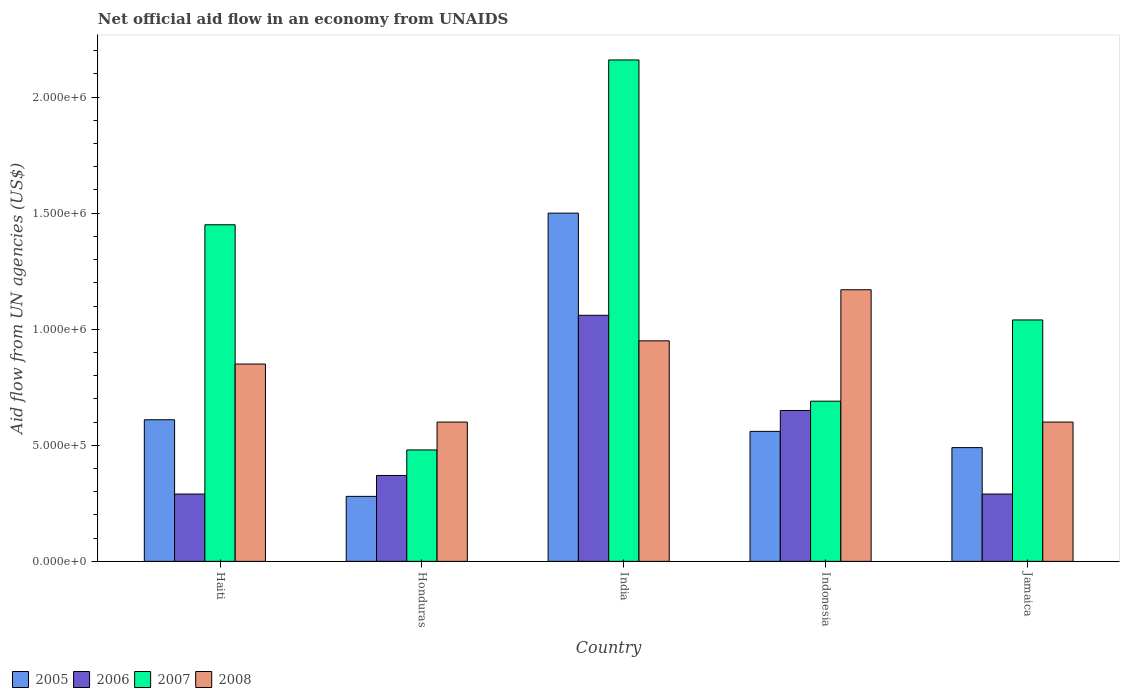How many groups of bars are there?
Offer a terse response. 5. Are the number of bars per tick equal to the number of legend labels?
Give a very brief answer. Yes. Are the number of bars on each tick of the X-axis equal?
Your answer should be compact. Yes. What is the label of the 5th group of bars from the left?
Offer a terse response. Jamaica. In how many cases, is the number of bars for a given country not equal to the number of legend labels?
Your response must be concise. 0. Across all countries, what is the maximum net official aid flow in 2008?
Your response must be concise. 1.17e+06. In which country was the net official aid flow in 2007 maximum?
Keep it short and to the point. India. In which country was the net official aid flow in 2007 minimum?
Provide a short and direct response. Honduras. What is the total net official aid flow in 2008 in the graph?
Provide a succinct answer. 4.17e+06. What is the difference between the net official aid flow in 2006 in Honduras and the net official aid flow in 2005 in India?
Your response must be concise. -1.13e+06. What is the average net official aid flow in 2008 per country?
Your answer should be very brief. 8.34e+05. What is the difference between the net official aid flow of/in 2008 and net official aid flow of/in 2005 in Jamaica?
Offer a terse response. 1.10e+05. In how many countries, is the net official aid flow in 2008 greater than 900000 US$?
Your response must be concise. 2. What is the difference between the highest and the second highest net official aid flow in 2005?
Your response must be concise. 9.40e+05. What is the difference between the highest and the lowest net official aid flow in 2005?
Your response must be concise. 1.22e+06. In how many countries, is the net official aid flow in 2007 greater than the average net official aid flow in 2007 taken over all countries?
Your answer should be very brief. 2. Is the sum of the net official aid flow in 2005 in India and Indonesia greater than the maximum net official aid flow in 2007 across all countries?
Ensure brevity in your answer.  No. Is it the case that in every country, the sum of the net official aid flow in 2005 and net official aid flow in 2007 is greater than the net official aid flow in 2006?
Make the answer very short. Yes. How many bars are there?
Keep it short and to the point. 20. Does the graph contain grids?
Provide a succinct answer. No. Where does the legend appear in the graph?
Offer a very short reply. Bottom left. How many legend labels are there?
Provide a short and direct response. 4. How are the legend labels stacked?
Offer a very short reply. Horizontal. What is the title of the graph?
Ensure brevity in your answer.  Net official aid flow in an economy from UNAIDS. What is the label or title of the X-axis?
Ensure brevity in your answer.  Country. What is the label or title of the Y-axis?
Offer a terse response. Aid flow from UN agencies (US$). What is the Aid flow from UN agencies (US$) of 2005 in Haiti?
Provide a succinct answer. 6.10e+05. What is the Aid flow from UN agencies (US$) of 2006 in Haiti?
Your answer should be compact. 2.90e+05. What is the Aid flow from UN agencies (US$) in 2007 in Haiti?
Your answer should be compact. 1.45e+06. What is the Aid flow from UN agencies (US$) of 2008 in Haiti?
Provide a short and direct response. 8.50e+05. What is the Aid flow from UN agencies (US$) of 2005 in India?
Keep it short and to the point. 1.50e+06. What is the Aid flow from UN agencies (US$) of 2006 in India?
Keep it short and to the point. 1.06e+06. What is the Aid flow from UN agencies (US$) of 2007 in India?
Keep it short and to the point. 2.16e+06. What is the Aid flow from UN agencies (US$) in 2008 in India?
Your answer should be very brief. 9.50e+05. What is the Aid flow from UN agencies (US$) of 2005 in Indonesia?
Provide a succinct answer. 5.60e+05. What is the Aid flow from UN agencies (US$) in 2006 in Indonesia?
Keep it short and to the point. 6.50e+05. What is the Aid flow from UN agencies (US$) of 2007 in Indonesia?
Ensure brevity in your answer.  6.90e+05. What is the Aid flow from UN agencies (US$) of 2008 in Indonesia?
Offer a terse response. 1.17e+06. What is the Aid flow from UN agencies (US$) in 2007 in Jamaica?
Offer a terse response. 1.04e+06. Across all countries, what is the maximum Aid flow from UN agencies (US$) in 2005?
Offer a very short reply. 1.50e+06. Across all countries, what is the maximum Aid flow from UN agencies (US$) of 2006?
Provide a short and direct response. 1.06e+06. Across all countries, what is the maximum Aid flow from UN agencies (US$) of 2007?
Your answer should be very brief. 2.16e+06. Across all countries, what is the maximum Aid flow from UN agencies (US$) in 2008?
Your answer should be very brief. 1.17e+06. Across all countries, what is the minimum Aid flow from UN agencies (US$) of 2006?
Ensure brevity in your answer.  2.90e+05. What is the total Aid flow from UN agencies (US$) in 2005 in the graph?
Keep it short and to the point. 3.44e+06. What is the total Aid flow from UN agencies (US$) in 2006 in the graph?
Your answer should be compact. 2.66e+06. What is the total Aid flow from UN agencies (US$) of 2007 in the graph?
Your answer should be compact. 5.82e+06. What is the total Aid flow from UN agencies (US$) in 2008 in the graph?
Your answer should be compact. 4.17e+06. What is the difference between the Aid flow from UN agencies (US$) in 2005 in Haiti and that in Honduras?
Keep it short and to the point. 3.30e+05. What is the difference between the Aid flow from UN agencies (US$) of 2007 in Haiti and that in Honduras?
Offer a terse response. 9.70e+05. What is the difference between the Aid flow from UN agencies (US$) of 2008 in Haiti and that in Honduras?
Give a very brief answer. 2.50e+05. What is the difference between the Aid flow from UN agencies (US$) of 2005 in Haiti and that in India?
Provide a short and direct response. -8.90e+05. What is the difference between the Aid flow from UN agencies (US$) in 2006 in Haiti and that in India?
Offer a very short reply. -7.70e+05. What is the difference between the Aid flow from UN agencies (US$) in 2007 in Haiti and that in India?
Make the answer very short. -7.10e+05. What is the difference between the Aid flow from UN agencies (US$) in 2008 in Haiti and that in India?
Your answer should be compact. -1.00e+05. What is the difference between the Aid flow from UN agencies (US$) in 2005 in Haiti and that in Indonesia?
Give a very brief answer. 5.00e+04. What is the difference between the Aid flow from UN agencies (US$) of 2006 in Haiti and that in Indonesia?
Your answer should be compact. -3.60e+05. What is the difference between the Aid flow from UN agencies (US$) of 2007 in Haiti and that in Indonesia?
Provide a short and direct response. 7.60e+05. What is the difference between the Aid flow from UN agencies (US$) in 2008 in Haiti and that in Indonesia?
Your answer should be very brief. -3.20e+05. What is the difference between the Aid flow from UN agencies (US$) in 2007 in Haiti and that in Jamaica?
Your answer should be very brief. 4.10e+05. What is the difference between the Aid flow from UN agencies (US$) in 2008 in Haiti and that in Jamaica?
Make the answer very short. 2.50e+05. What is the difference between the Aid flow from UN agencies (US$) of 2005 in Honduras and that in India?
Offer a very short reply. -1.22e+06. What is the difference between the Aid flow from UN agencies (US$) in 2006 in Honduras and that in India?
Your answer should be compact. -6.90e+05. What is the difference between the Aid flow from UN agencies (US$) in 2007 in Honduras and that in India?
Your response must be concise. -1.68e+06. What is the difference between the Aid flow from UN agencies (US$) in 2008 in Honduras and that in India?
Your answer should be very brief. -3.50e+05. What is the difference between the Aid flow from UN agencies (US$) of 2005 in Honduras and that in Indonesia?
Ensure brevity in your answer.  -2.80e+05. What is the difference between the Aid flow from UN agencies (US$) of 2006 in Honduras and that in Indonesia?
Make the answer very short. -2.80e+05. What is the difference between the Aid flow from UN agencies (US$) of 2008 in Honduras and that in Indonesia?
Make the answer very short. -5.70e+05. What is the difference between the Aid flow from UN agencies (US$) of 2005 in Honduras and that in Jamaica?
Your answer should be compact. -2.10e+05. What is the difference between the Aid flow from UN agencies (US$) in 2007 in Honduras and that in Jamaica?
Your response must be concise. -5.60e+05. What is the difference between the Aid flow from UN agencies (US$) of 2005 in India and that in Indonesia?
Your response must be concise. 9.40e+05. What is the difference between the Aid flow from UN agencies (US$) in 2007 in India and that in Indonesia?
Your answer should be compact. 1.47e+06. What is the difference between the Aid flow from UN agencies (US$) in 2008 in India and that in Indonesia?
Ensure brevity in your answer.  -2.20e+05. What is the difference between the Aid flow from UN agencies (US$) in 2005 in India and that in Jamaica?
Your response must be concise. 1.01e+06. What is the difference between the Aid flow from UN agencies (US$) in 2006 in India and that in Jamaica?
Your response must be concise. 7.70e+05. What is the difference between the Aid flow from UN agencies (US$) of 2007 in India and that in Jamaica?
Ensure brevity in your answer.  1.12e+06. What is the difference between the Aid flow from UN agencies (US$) of 2007 in Indonesia and that in Jamaica?
Your response must be concise. -3.50e+05. What is the difference between the Aid flow from UN agencies (US$) of 2008 in Indonesia and that in Jamaica?
Ensure brevity in your answer.  5.70e+05. What is the difference between the Aid flow from UN agencies (US$) in 2005 in Haiti and the Aid flow from UN agencies (US$) in 2007 in Honduras?
Provide a short and direct response. 1.30e+05. What is the difference between the Aid flow from UN agencies (US$) of 2006 in Haiti and the Aid flow from UN agencies (US$) of 2008 in Honduras?
Your response must be concise. -3.10e+05. What is the difference between the Aid flow from UN agencies (US$) in 2007 in Haiti and the Aid flow from UN agencies (US$) in 2008 in Honduras?
Give a very brief answer. 8.50e+05. What is the difference between the Aid flow from UN agencies (US$) of 2005 in Haiti and the Aid flow from UN agencies (US$) of 2006 in India?
Keep it short and to the point. -4.50e+05. What is the difference between the Aid flow from UN agencies (US$) in 2005 in Haiti and the Aid flow from UN agencies (US$) in 2007 in India?
Your answer should be very brief. -1.55e+06. What is the difference between the Aid flow from UN agencies (US$) in 2006 in Haiti and the Aid flow from UN agencies (US$) in 2007 in India?
Your answer should be compact. -1.87e+06. What is the difference between the Aid flow from UN agencies (US$) of 2006 in Haiti and the Aid flow from UN agencies (US$) of 2008 in India?
Ensure brevity in your answer.  -6.60e+05. What is the difference between the Aid flow from UN agencies (US$) in 2007 in Haiti and the Aid flow from UN agencies (US$) in 2008 in India?
Provide a succinct answer. 5.00e+05. What is the difference between the Aid flow from UN agencies (US$) in 2005 in Haiti and the Aid flow from UN agencies (US$) in 2008 in Indonesia?
Make the answer very short. -5.60e+05. What is the difference between the Aid flow from UN agencies (US$) of 2006 in Haiti and the Aid flow from UN agencies (US$) of 2007 in Indonesia?
Your response must be concise. -4.00e+05. What is the difference between the Aid flow from UN agencies (US$) in 2006 in Haiti and the Aid flow from UN agencies (US$) in 2008 in Indonesia?
Offer a terse response. -8.80e+05. What is the difference between the Aid flow from UN agencies (US$) of 2005 in Haiti and the Aid flow from UN agencies (US$) of 2006 in Jamaica?
Your answer should be very brief. 3.20e+05. What is the difference between the Aid flow from UN agencies (US$) of 2005 in Haiti and the Aid flow from UN agencies (US$) of 2007 in Jamaica?
Make the answer very short. -4.30e+05. What is the difference between the Aid flow from UN agencies (US$) of 2005 in Haiti and the Aid flow from UN agencies (US$) of 2008 in Jamaica?
Your response must be concise. 10000. What is the difference between the Aid flow from UN agencies (US$) in 2006 in Haiti and the Aid flow from UN agencies (US$) in 2007 in Jamaica?
Keep it short and to the point. -7.50e+05. What is the difference between the Aid flow from UN agencies (US$) of 2006 in Haiti and the Aid flow from UN agencies (US$) of 2008 in Jamaica?
Offer a very short reply. -3.10e+05. What is the difference between the Aid flow from UN agencies (US$) of 2007 in Haiti and the Aid flow from UN agencies (US$) of 2008 in Jamaica?
Provide a succinct answer. 8.50e+05. What is the difference between the Aid flow from UN agencies (US$) of 2005 in Honduras and the Aid flow from UN agencies (US$) of 2006 in India?
Keep it short and to the point. -7.80e+05. What is the difference between the Aid flow from UN agencies (US$) of 2005 in Honduras and the Aid flow from UN agencies (US$) of 2007 in India?
Ensure brevity in your answer.  -1.88e+06. What is the difference between the Aid flow from UN agencies (US$) in 2005 in Honduras and the Aid flow from UN agencies (US$) in 2008 in India?
Keep it short and to the point. -6.70e+05. What is the difference between the Aid flow from UN agencies (US$) in 2006 in Honduras and the Aid flow from UN agencies (US$) in 2007 in India?
Provide a succinct answer. -1.79e+06. What is the difference between the Aid flow from UN agencies (US$) in 2006 in Honduras and the Aid flow from UN agencies (US$) in 2008 in India?
Give a very brief answer. -5.80e+05. What is the difference between the Aid flow from UN agencies (US$) of 2007 in Honduras and the Aid flow from UN agencies (US$) of 2008 in India?
Your response must be concise. -4.70e+05. What is the difference between the Aid flow from UN agencies (US$) in 2005 in Honduras and the Aid flow from UN agencies (US$) in 2006 in Indonesia?
Make the answer very short. -3.70e+05. What is the difference between the Aid flow from UN agencies (US$) of 2005 in Honduras and the Aid flow from UN agencies (US$) of 2007 in Indonesia?
Your answer should be very brief. -4.10e+05. What is the difference between the Aid flow from UN agencies (US$) in 2005 in Honduras and the Aid flow from UN agencies (US$) in 2008 in Indonesia?
Your response must be concise. -8.90e+05. What is the difference between the Aid flow from UN agencies (US$) of 2006 in Honduras and the Aid flow from UN agencies (US$) of 2007 in Indonesia?
Offer a very short reply. -3.20e+05. What is the difference between the Aid flow from UN agencies (US$) of 2006 in Honduras and the Aid flow from UN agencies (US$) of 2008 in Indonesia?
Give a very brief answer. -8.00e+05. What is the difference between the Aid flow from UN agencies (US$) of 2007 in Honduras and the Aid flow from UN agencies (US$) of 2008 in Indonesia?
Your response must be concise. -6.90e+05. What is the difference between the Aid flow from UN agencies (US$) of 2005 in Honduras and the Aid flow from UN agencies (US$) of 2007 in Jamaica?
Provide a succinct answer. -7.60e+05. What is the difference between the Aid flow from UN agencies (US$) of 2005 in Honduras and the Aid flow from UN agencies (US$) of 2008 in Jamaica?
Your response must be concise. -3.20e+05. What is the difference between the Aid flow from UN agencies (US$) of 2006 in Honduras and the Aid flow from UN agencies (US$) of 2007 in Jamaica?
Make the answer very short. -6.70e+05. What is the difference between the Aid flow from UN agencies (US$) of 2005 in India and the Aid flow from UN agencies (US$) of 2006 in Indonesia?
Offer a terse response. 8.50e+05. What is the difference between the Aid flow from UN agencies (US$) in 2005 in India and the Aid flow from UN agencies (US$) in 2007 in Indonesia?
Offer a very short reply. 8.10e+05. What is the difference between the Aid flow from UN agencies (US$) in 2006 in India and the Aid flow from UN agencies (US$) in 2008 in Indonesia?
Your answer should be compact. -1.10e+05. What is the difference between the Aid flow from UN agencies (US$) in 2007 in India and the Aid flow from UN agencies (US$) in 2008 in Indonesia?
Keep it short and to the point. 9.90e+05. What is the difference between the Aid flow from UN agencies (US$) of 2005 in India and the Aid flow from UN agencies (US$) of 2006 in Jamaica?
Your response must be concise. 1.21e+06. What is the difference between the Aid flow from UN agencies (US$) of 2005 in India and the Aid flow from UN agencies (US$) of 2007 in Jamaica?
Your response must be concise. 4.60e+05. What is the difference between the Aid flow from UN agencies (US$) of 2006 in India and the Aid flow from UN agencies (US$) of 2008 in Jamaica?
Make the answer very short. 4.60e+05. What is the difference between the Aid flow from UN agencies (US$) in 2007 in India and the Aid flow from UN agencies (US$) in 2008 in Jamaica?
Offer a terse response. 1.56e+06. What is the difference between the Aid flow from UN agencies (US$) of 2005 in Indonesia and the Aid flow from UN agencies (US$) of 2007 in Jamaica?
Keep it short and to the point. -4.80e+05. What is the difference between the Aid flow from UN agencies (US$) of 2006 in Indonesia and the Aid flow from UN agencies (US$) of 2007 in Jamaica?
Make the answer very short. -3.90e+05. What is the difference between the Aid flow from UN agencies (US$) in 2006 in Indonesia and the Aid flow from UN agencies (US$) in 2008 in Jamaica?
Offer a very short reply. 5.00e+04. What is the average Aid flow from UN agencies (US$) in 2005 per country?
Ensure brevity in your answer.  6.88e+05. What is the average Aid flow from UN agencies (US$) in 2006 per country?
Provide a short and direct response. 5.32e+05. What is the average Aid flow from UN agencies (US$) in 2007 per country?
Keep it short and to the point. 1.16e+06. What is the average Aid flow from UN agencies (US$) in 2008 per country?
Offer a very short reply. 8.34e+05. What is the difference between the Aid flow from UN agencies (US$) in 2005 and Aid flow from UN agencies (US$) in 2007 in Haiti?
Keep it short and to the point. -8.40e+05. What is the difference between the Aid flow from UN agencies (US$) of 2005 and Aid flow from UN agencies (US$) of 2008 in Haiti?
Ensure brevity in your answer.  -2.40e+05. What is the difference between the Aid flow from UN agencies (US$) in 2006 and Aid flow from UN agencies (US$) in 2007 in Haiti?
Offer a very short reply. -1.16e+06. What is the difference between the Aid flow from UN agencies (US$) in 2006 and Aid flow from UN agencies (US$) in 2008 in Haiti?
Provide a short and direct response. -5.60e+05. What is the difference between the Aid flow from UN agencies (US$) in 2005 and Aid flow from UN agencies (US$) in 2006 in Honduras?
Offer a terse response. -9.00e+04. What is the difference between the Aid flow from UN agencies (US$) in 2005 and Aid flow from UN agencies (US$) in 2008 in Honduras?
Provide a succinct answer. -3.20e+05. What is the difference between the Aid flow from UN agencies (US$) of 2006 and Aid flow from UN agencies (US$) of 2007 in Honduras?
Provide a short and direct response. -1.10e+05. What is the difference between the Aid flow from UN agencies (US$) in 2006 and Aid flow from UN agencies (US$) in 2008 in Honduras?
Keep it short and to the point. -2.30e+05. What is the difference between the Aid flow from UN agencies (US$) in 2005 and Aid flow from UN agencies (US$) in 2007 in India?
Your answer should be compact. -6.60e+05. What is the difference between the Aid flow from UN agencies (US$) in 2005 and Aid flow from UN agencies (US$) in 2008 in India?
Offer a very short reply. 5.50e+05. What is the difference between the Aid flow from UN agencies (US$) in 2006 and Aid flow from UN agencies (US$) in 2007 in India?
Offer a terse response. -1.10e+06. What is the difference between the Aid flow from UN agencies (US$) of 2007 and Aid flow from UN agencies (US$) of 2008 in India?
Give a very brief answer. 1.21e+06. What is the difference between the Aid flow from UN agencies (US$) of 2005 and Aid flow from UN agencies (US$) of 2006 in Indonesia?
Ensure brevity in your answer.  -9.00e+04. What is the difference between the Aid flow from UN agencies (US$) of 2005 and Aid flow from UN agencies (US$) of 2007 in Indonesia?
Provide a short and direct response. -1.30e+05. What is the difference between the Aid flow from UN agencies (US$) of 2005 and Aid flow from UN agencies (US$) of 2008 in Indonesia?
Give a very brief answer. -6.10e+05. What is the difference between the Aid flow from UN agencies (US$) of 2006 and Aid flow from UN agencies (US$) of 2007 in Indonesia?
Keep it short and to the point. -4.00e+04. What is the difference between the Aid flow from UN agencies (US$) in 2006 and Aid flow from UN agencies (US$) in 2008 in Indonesia?
Make the answer very short. -5.20e+05. What is the difference between the Aid flow from UN agencies (US$) of 2007 and Aid flow from UN agencies (US$) of 2008 in Indonesia?
Give a very brief answer. -4.80e+05. What is the difference between the Aid flow from UN agencies (US$) of 2005 and Aid flow from UN agencies (US$) of 2007 in Jamaica?
Give a very brief answer. -5.50e+05. What is the difference between the Aid flow from UN agencies (US$) of 2006 and Aid flow from UN agencies (US$) of 2007 in Jamaica?
Offer a very short reply. -7.50e+05. What is the difference between the Aid flow from UN agencies (US$) of 2006 and Aid flow from UN agencies (US$) of 2008 in Jamaica?
Provide a short and direct response. -3.10e+05. What is the difference between the Aid flow from UN agencies (US$) of 2007 and Aid flow from UN agencies (US$) of 2008 in Jamaica?
Offer a terse response. 4.40e+05. What is the ratio of the Aid flow from UN agencies (US$) of 2005 in Haiti to that in Honduras?
Offer a terse response. 2.18. What is the ratio of the Aid flow from UN agencies (US$) in 2006 in Haiti to that in Honduras?
Your response must be concise. 0.78. What is the ratio of the Aid flow from UN agencies (US$) of 2007 in Haiti to that in Honduras?
Offer a very short reply. 3.02. What is the ratio of the Aid flow from UN agencies (US$) in 2008 in Haiti to that in Honduras?
Offer a very short reply. 1.42. What is the ratio of the Aid flow from UN agencies (US$) of 2005 in Haiti to that in India?
Keep it short and to the point. 0.41. What is the ratio of the Aid flow from UN agencies (US$) of 2006 in Haiti to that in India?
Your answer should be compact. 0.27. What is the ratio of the Aid flow from UN agencies (US$) in 2007 in Haiti to that in India?
Offer a terse response. 0.67. What is the ratio of the Aid flow from UN agencies (US$) of 2008 in Haiti to that in India?
Offer a very short reply. 0.89. What is the ratio of the Aid flow from UN agencies (US$) of 2005 in Haiti to that in Indonesia?
Make the answer very short. 1.09. What is the ratio of the Aid flow from UN agencies (US$) of 2006 in Haiti to that in Indonesia?
Your answer should be very brief. 0.45. What is the ratio of the Aid flow from UN agencies (US$) of 2007 in Haiti to that in Indonesia?
Provide a succinct answer. 2.1. What is the ratio of the Aid flow from UN agencies (US$) in 2008 in Haiti to that in Indonesia?
Offer a very short reply. 0.73. What is the ratio of the Aid flow from UN agencies (US$) in 2005 in Haiti to that in Jamaica?
Give a very brief answer. 1.24. What is the ratio of the Aid flow from UN agencies (US$) in 2006 in Haiti to that in Jamaica?
Offer a very short reply. 1. What is the ratio of the Aid flow from UN agencies (US$) of 2007 in Haiti to that in Jamaica?
Provide a succinct answer. 1.39. What is the ratio of the Aid flow from UN agencies (US$) of 2008 in Haiti to that in Jamaica?
Your response must be concise. 1.42. What is the ratio of the Aid flow from UN agencies (US$) of 2005 in Honduras to that in India?
Your answer should be compact. 0.19. What is the ratio of the Aid flow from UN agencies (US$) in 2006 in Honduras to that in India?
Give a very brief answer. 0.35. What is the ratio of the Aid flow from UN agencies (US$) of 2007 in Honduras to that in India?
Make the answer very short. 0.22. What is the ratio of the Aid flow from UN agencies (US$) in 2008 in Honduras to that in India?
Provide a succinct answer. 0.63. What is the ratio of the Aid flow from UN agencies (US$) of 2005 in Honduras to that in Indonesia?
Make the answer very short. 0.5. What is the ratio of the Aid flow from UN agencies (US$) of 2006 in Honduras to that in Indonesia?
Offer a terse response. 0.57. What is the ratio of the Aid flow from UN agencies (US$) of 2007 in Honduras to that in Indonesia?
Keep it short and to the point. 0.7. What is the ratio of the Aid flow from UN agencies (US$) of 2008 in Honduras to that in Indonesia?
Provide a short and direct response. 0.51. What is the ratio of the Aid flow from UN agencies (US$) of 2006 in Honduras to that in Jamaica?
Give a very brief answer. 1.28. What is the ratio of the Aid flow from UN agencies (US$) of 2007 in Honduras to that in Jamaica?
Offer a terse response. 0.46. What is the ratio of the Aid flow from UN agencies (US$) in 2005 in India to that in Indonesia?
Make the answer very short. 2.68. What is the ratio of the Aid flow from UN agencies (US$) in 2006 in India to that in Indonesia?
Ensure brevity in your answer.  1.63. What is the ratio of the Aid flow from UN agencies (US$) of 2007 in India to that in Indonesia?
Provide a short and direct response. 3.13. What is the ratio of the Aid flow from UN agencies (US$) in 2008 in India to that in Indonesia?
Keep it short and to the point. 0.81. What is the ratio of the Aid flow from UN agencies (US$) in 2005 in India to that in Jamaica?
Ensure brevity in your answer.  3.06. What is the ratio of the Aid flow from UN agencies (US$) of 2006 in India to that in Jamaica?
Provide a succinct answer. 3.66. What is the ratio of the Aid flow from UN agencies (US$) of 2007 in India to that in Jamaica?
Your answer should be compact. 2.08. What is the ratio of the Aid flow from UN agencies (US$) of 2008 in India to that in Jamaica?
Give a very brief answer. 1.58. What is the ratio of the Aid flow from UN agencies (US$) in 2005 in Indonesia to that in Jamaica?
Give a very brief answer. 1.14. What is the ratio of the Aid flow from UN agencies (US$) in 2006 in Indonesia to that in Jamaica?
Offer a terse response. 2.24. What is the ratio of the Aid flow from UN agencies (US$) of 2007 in Indonesia to that in Jamaica?
Make the answer very short. 0.66. What is the ratio of the Aid flow from UN agencies (US$) in 2008 in Indonesia to that in Jamaica?
Your answer should be compact. 1.95. What is the difference between the highest and the second highest Aid flow from UN agencies (US$) in 2005?
Offer a very short reply. 8.90e+05. What is the difference between the highest and the second highest Aid flow from UN agencies (US$) in 2007?
Give a very brief answer. 7.10e+05. What is the difference between the highest and the lowest Aid flow from UN agencies (US$) in 2005?
Offer a terse response. 1.22e+06. What is the difference between the highest and the lowest Aid flow from UN agencies (US$) of 2006?
Offer a terse response. 7.70e+05. What is the difference between the highest and the lowest Aid flow from UN agencies (US$) of 2007?
Provide a short and direct response. 1.68e+06. What is the difference between the highest and the lowest Aid flow from UN agencies (US$) of 2008?
Your response must be concise. 5.70e+05. 